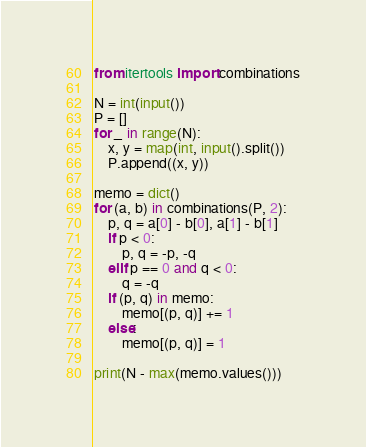Convert code to text. <code><loc_0><loc_0><loc_500><loc_500><_Python_>from itertools import combinations

N = int(input())
P = []
for _ in range(N):
    x, y = map(int, input().split())
    P.append((x, y))

memo = dict()
for (a, b) in combinations(P, 2):
    p, q = a[0] - b[0], a[1] - b[1]
    if p < 0:
        p, q = -p, -q
    elif p == 0 and q < 0:
        q = -q
    if (p, q) in memo:
        memo[(p, q)] += 1
    else:
        memo[(p, q)] = 1

print(N - max(memo.values()))
</code> 